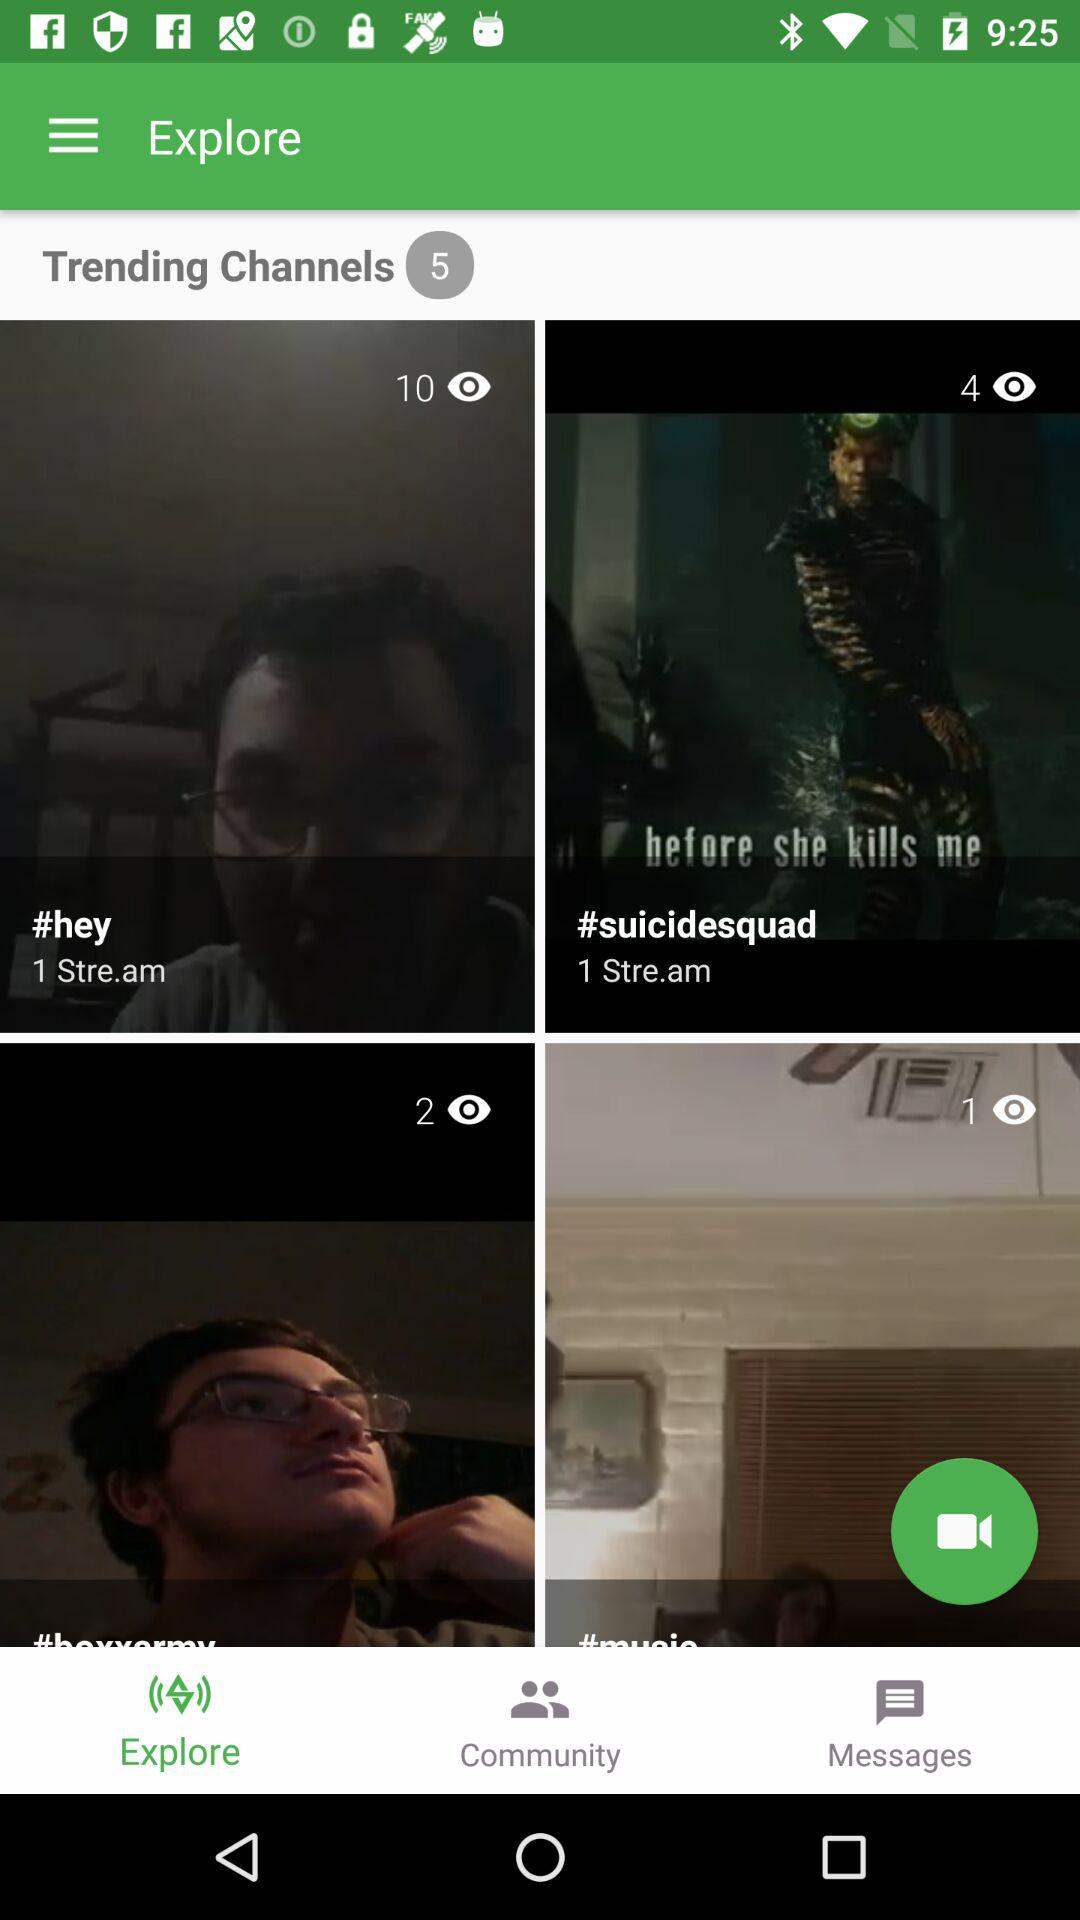Which tab has been selected? The selected tab is "Explore". 